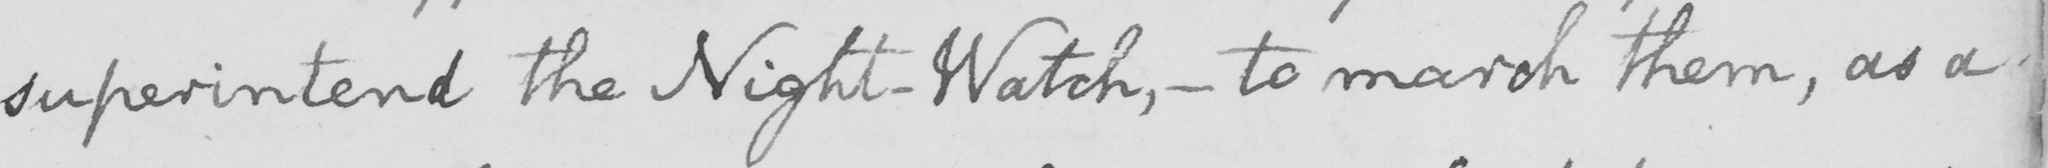What text is written in this handwritten line? superintend the Night-Watch ,  _  to march them , as a 